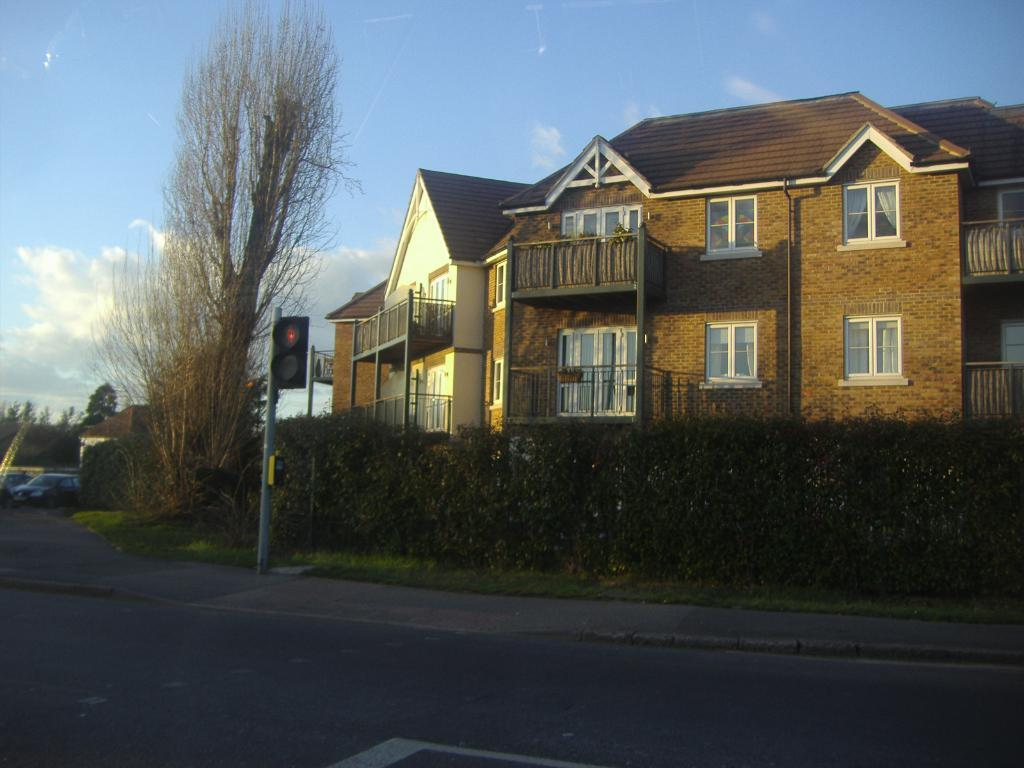What is the main feature of the image? There is a road in the image. What is located on the road? There is a pole with traffic signals on the road. What type of vegetation can be seen in the image? There are trees visible in the image. What type of structures are present in the image? There are buildings in the image. What is visible in the background of the image? The sky is visible in the image. Can you see any feathers floating in the air in the image? There are no feathers visible in the image. Is there a pig walking along the road in the image? There is no pig present in the image. 